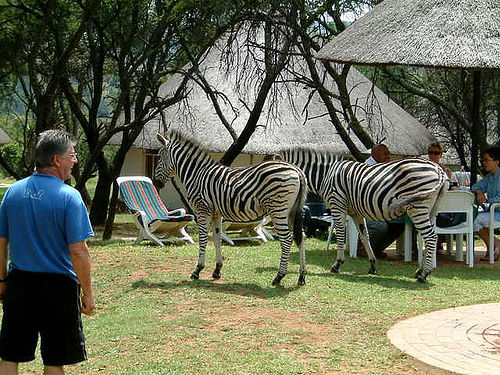Are the zebras accustomed to humans in this setting? Judging by their calm demeanor and proximity to humans, the zebras seem to be quite accustomed to human presence in this setting, which suggests that they may inhabit a protected area or sanctuary where they regularly interact with visitors. How can you tell the zebras are not alarmed? The zebras show relaxed body language, with no signs of tension or haste in their movements. Their comfort being near humans and lack of a flight response suggest that these interactions are normal for them. 